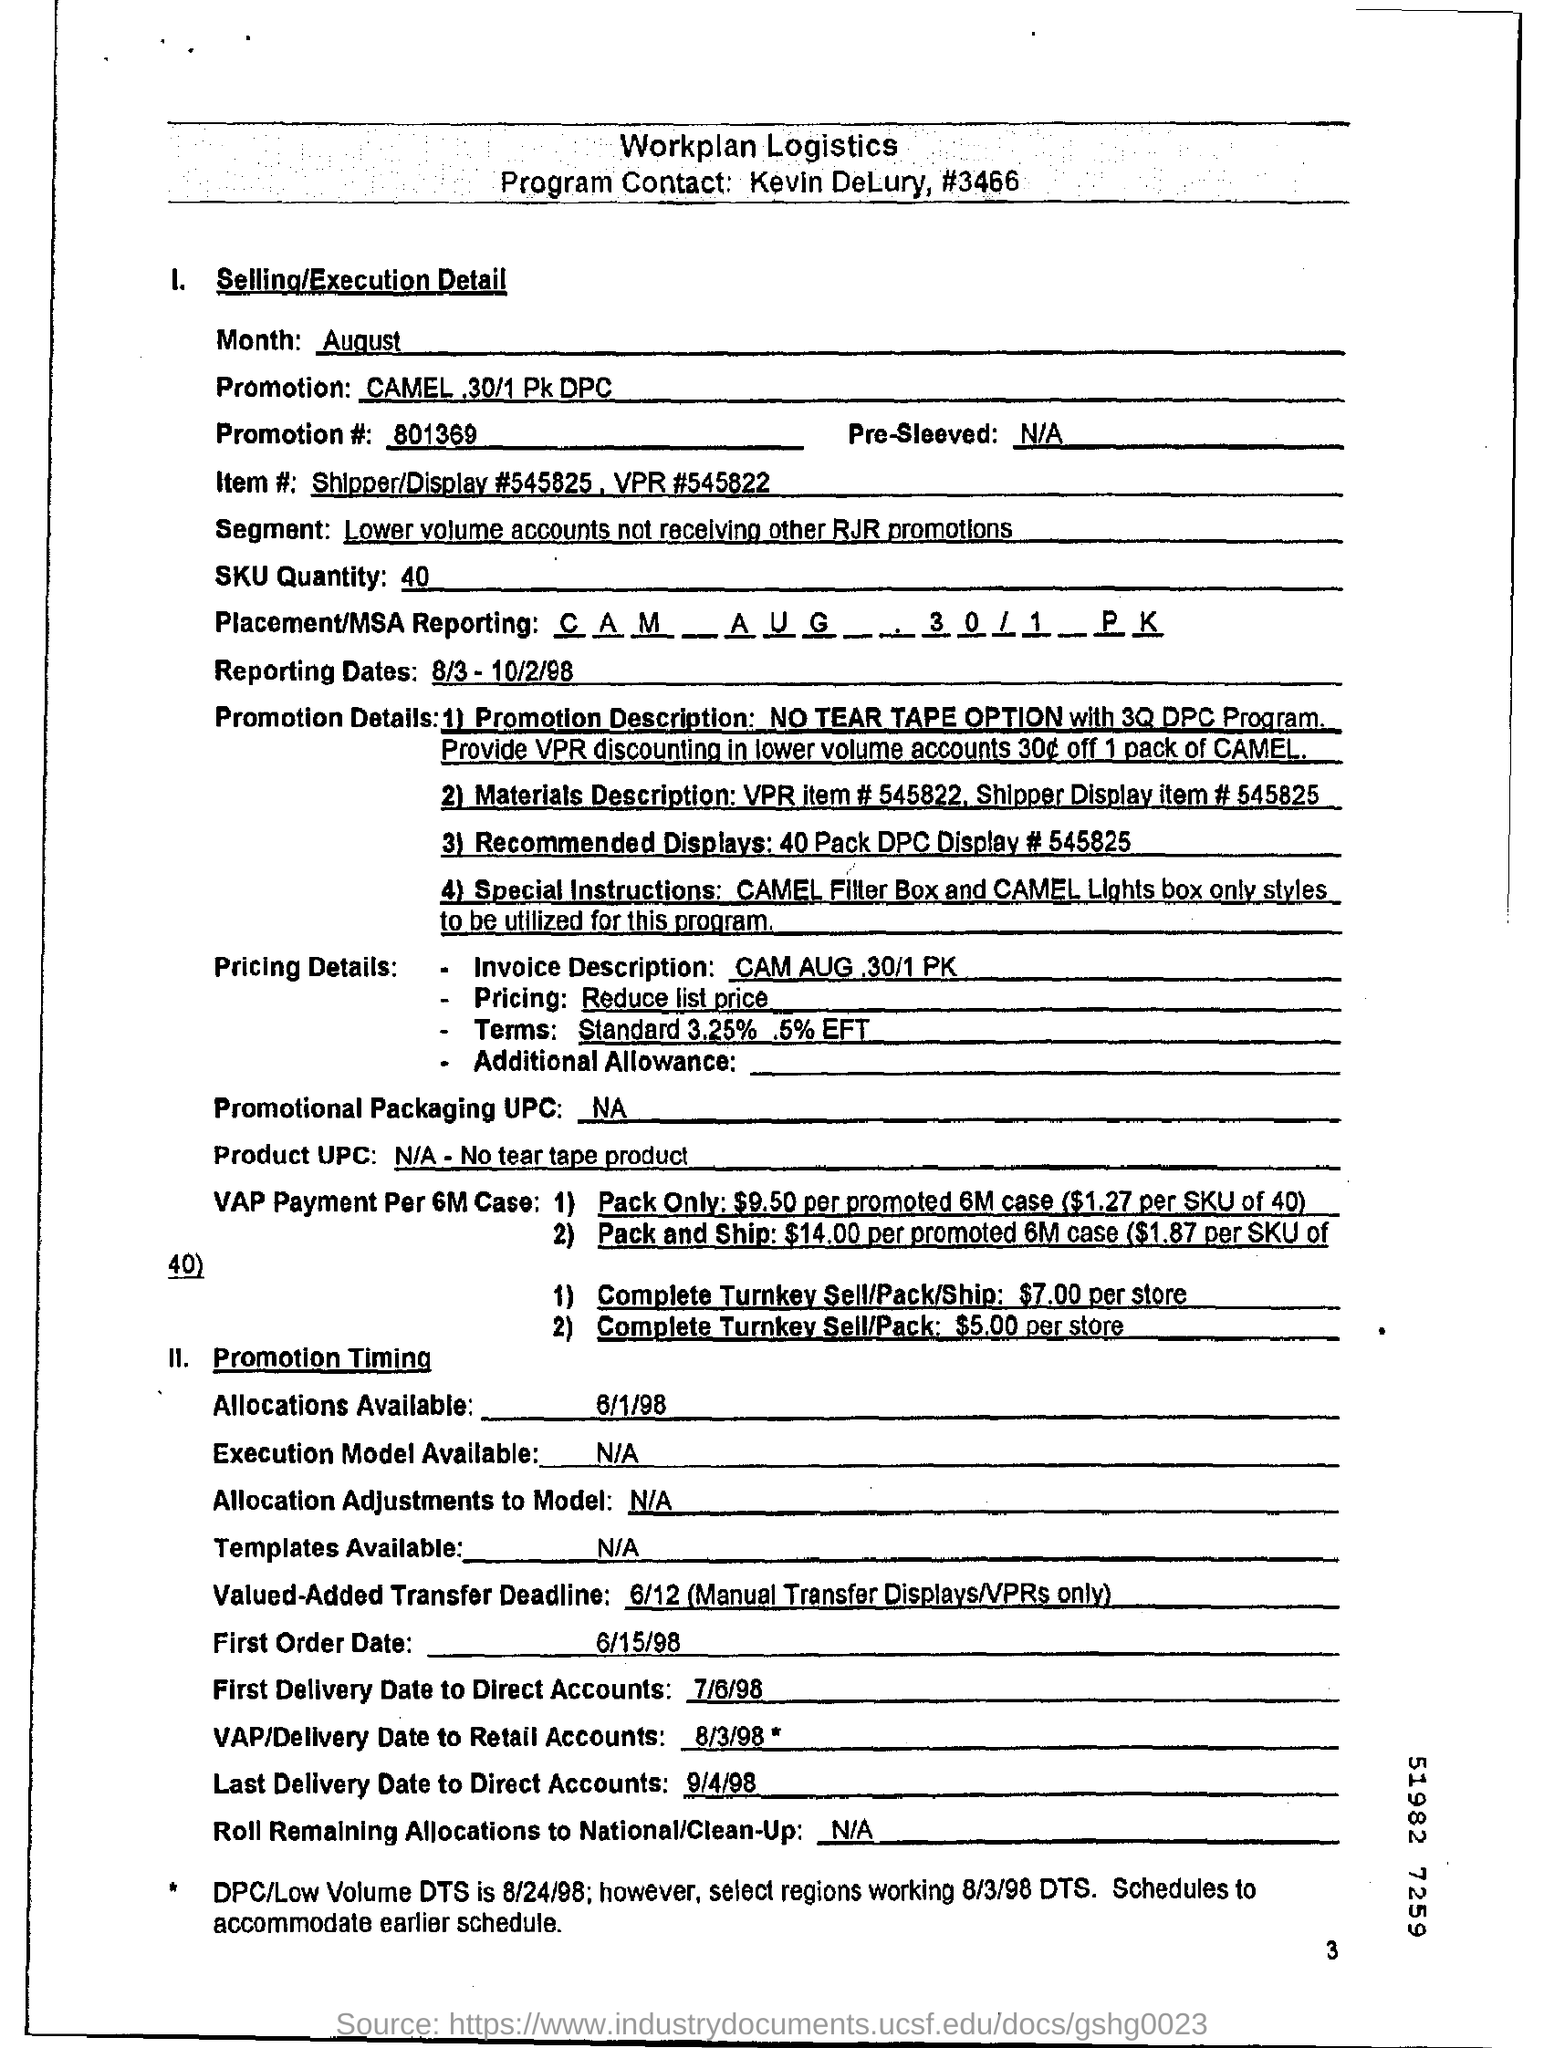How many number of promotion details are available?
Ensure brevity in your answer.  4. What is the SKU quantity?
Your answer should be very brief. 40. When is allocation available?
Keep it short and to the point. 6/1/98. When is the first order date?
Your answer should be very brief. 6/15/98. When is the last delivery date to direct accounts?
Provide a short and direct response. 9/4/98. 